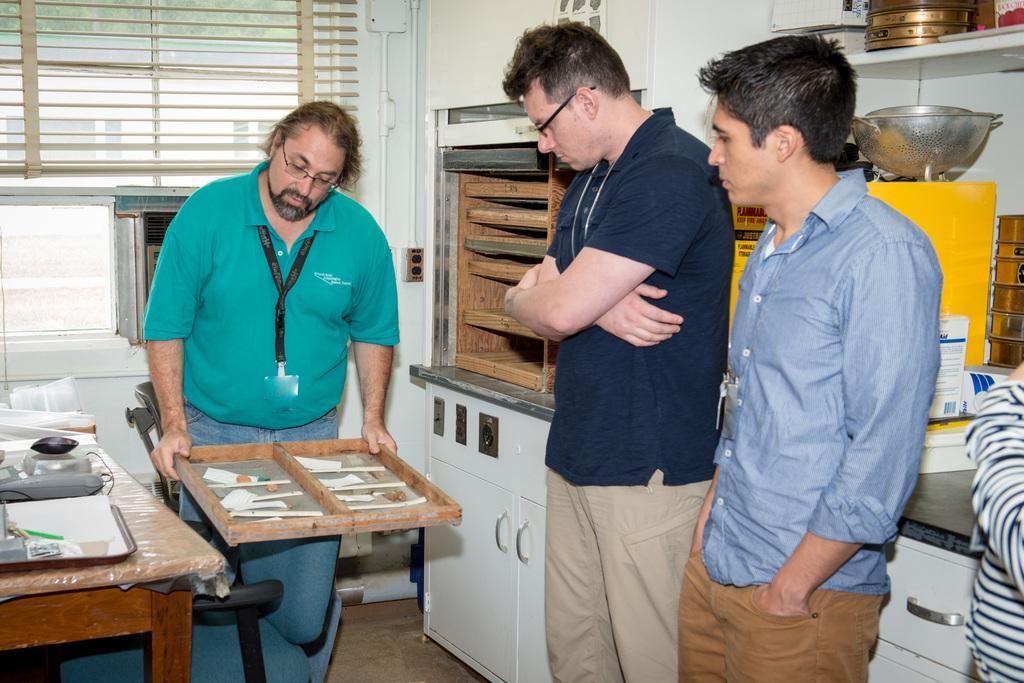Can you describe this image briefly? There are group of persons standing in this image. In the background there is a wardrobe, window, wall. The person in the center wearing a green colour t-shirt is holding an object in his hand. At the left side on the table there are objects kept. And at the right side there are three person standing. 